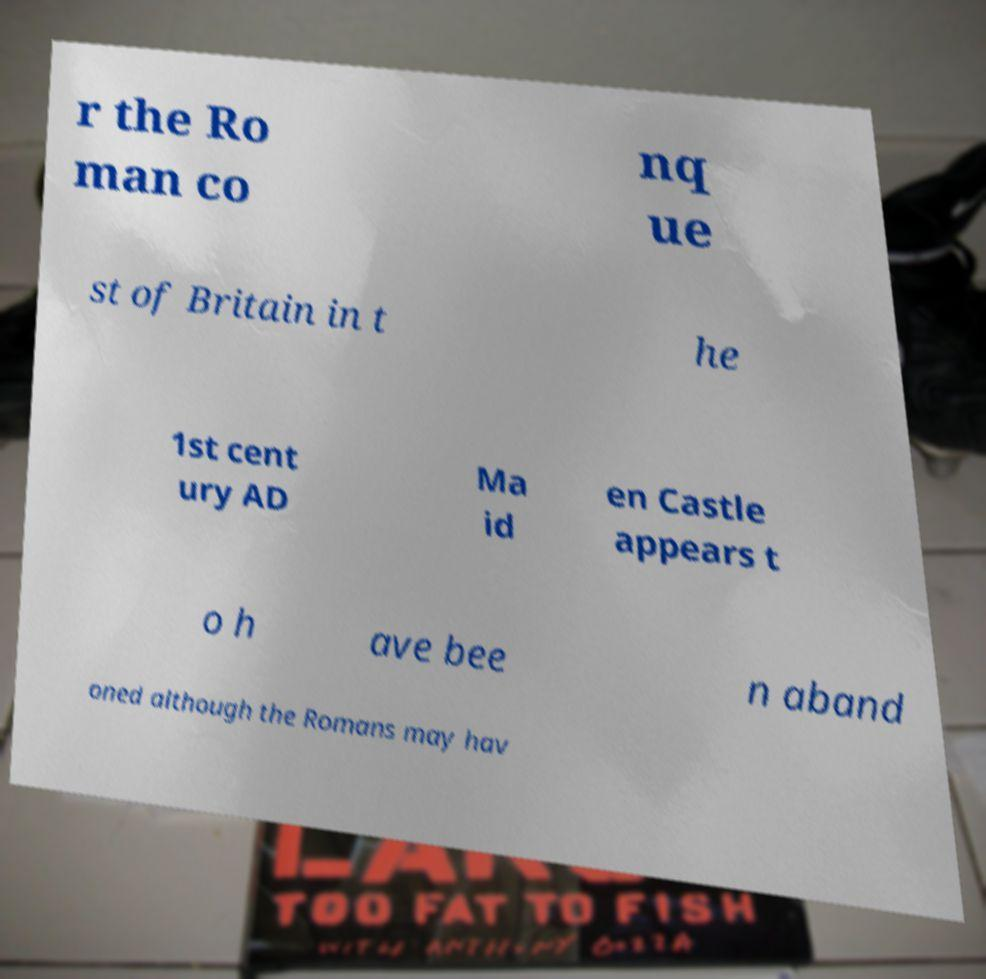Could you extract and type out the text from this image? r the Ro man co nq ue st of Britain in t he 1st cent ury AD Ma id en Castle appears t o h ave bee n aband oned although the Romans may hav 